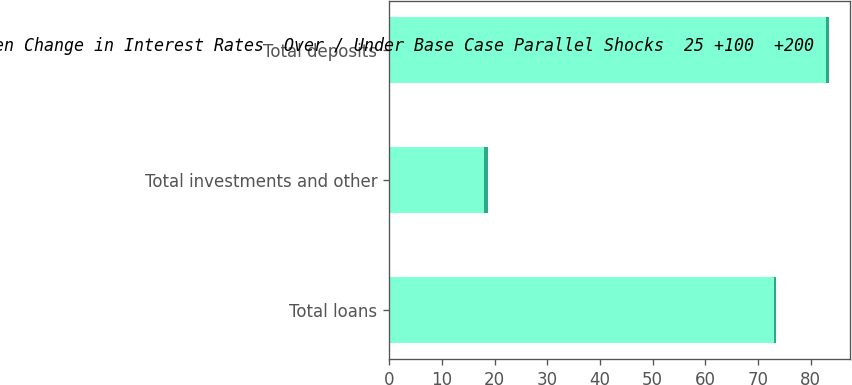Convert chart to OTSL. <chart><loc_0><loc_0><loc_500><loc_500><stacked_bar_chart><ecel><fcel>Total loans<fcel>Total investments and other<fcel>Total deposits<nl><fcel>Percent Change in Economic Value  For a Given Change in Interest Rates  Over / Under Base Case Parallel Shocks  25 +100  +200<fcel>73<fcel>18<fcel>83<nl><fcel>Percent of Total Net  Tangible<fcel>0.4<fcel>0.7<fcel>0.4<nl></chart> 